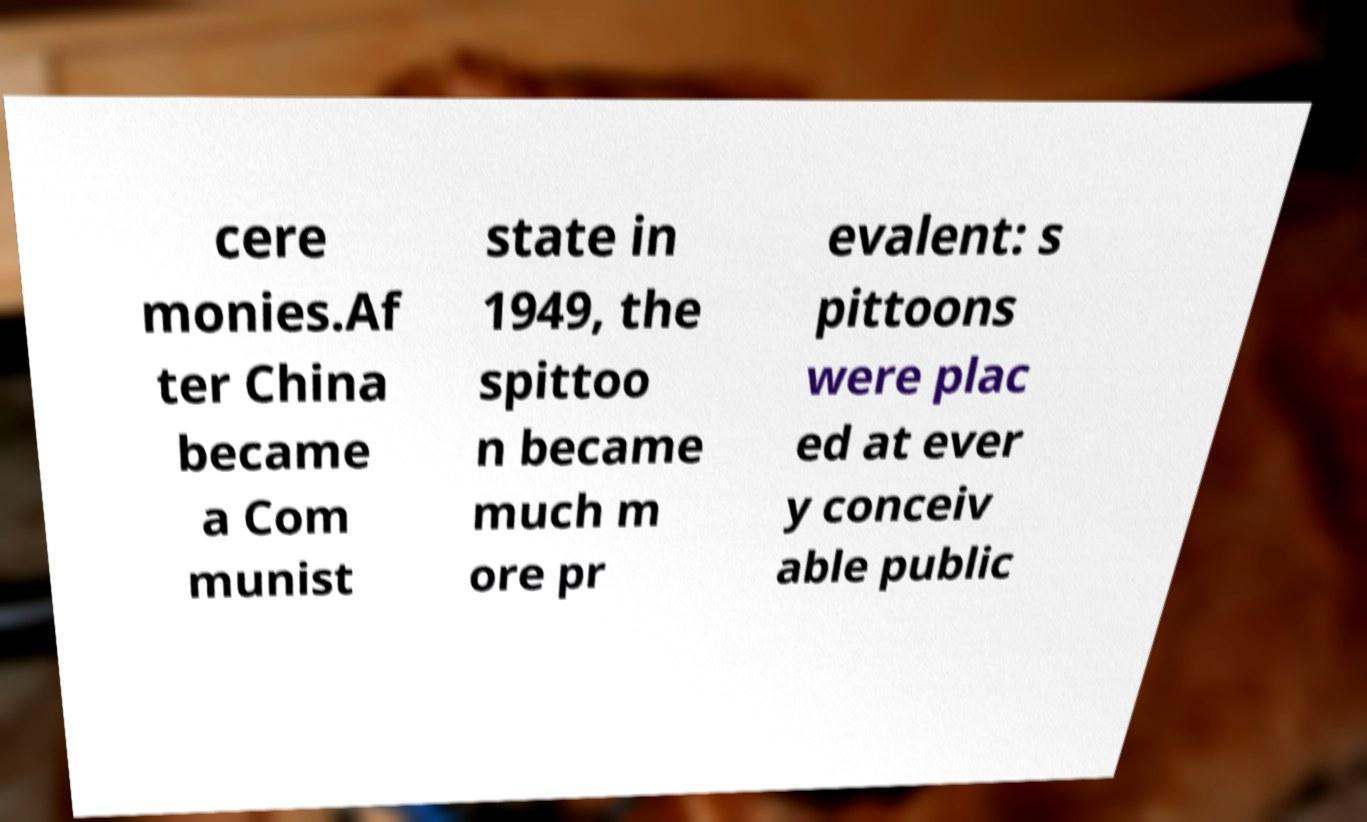I need the written content from this picture converted into text. Can you do that? cere monies.Af ter China became a Com munist state in 1949, the spittoo n became much m ore pr evalent: s pittoons were plac ed at ever y conceiv able public 